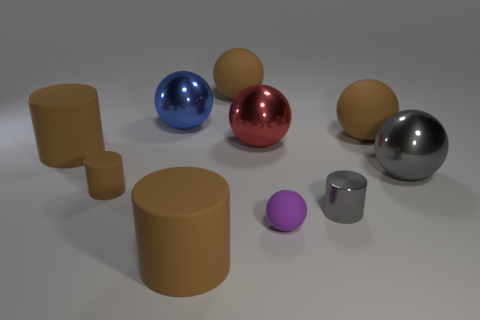What number of small metal things have the same color as the tiny matte cylinder?
Make the answer very short. 0. There is a metal ball that is behind the big gray sphere and to the right of the blue shiny ball; how big is it?
Offer a terse response. Large. Is the number of blue metal things that are on the left side of the large blue shiny ball less than the number of tiny cylinders?
Offer a terse response. Yes. Does the blue thing have the same material as the big gray thing?
Provide a succinct answer. Yes. How many things are small balls or rubber objects?
Your response must be concise. 6. How many large blue objects are the same material as the large red object?
Provide a short and direct response. 1. There is a purple object that is the same shape as the big blue shiny object; what size is it?
Make the answer very short. Small. Are there any blue spheres in front of the tiny sphere?
Offer a terse response. No. What material is the tiny gray thing?
Your response must be concise. Metal. There is a big matte thing to the right of the large red metallic sphere; is its color the same as the tiny rubber cylinder?
Keep it short and to the point. Yes. 